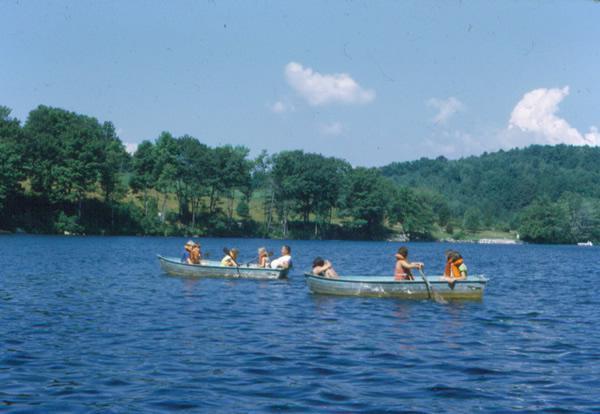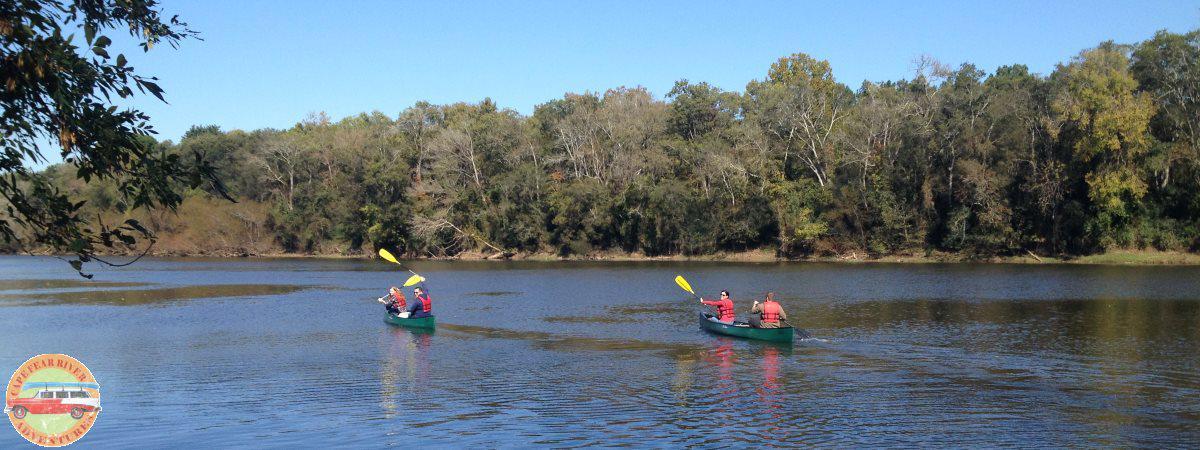The first image is the image on the left, the second image is the image on the right. For the images displayed, is the sentence "One of the images features a single canoe." factually correct? Answer yes or no. No. The first image is the image on the left, the second image is the image on the right. Analyze the images presented: Is the assertion "Two green canoes are parallel to each other on the water, in the right image." valid? Answer yes or no. Yes. 